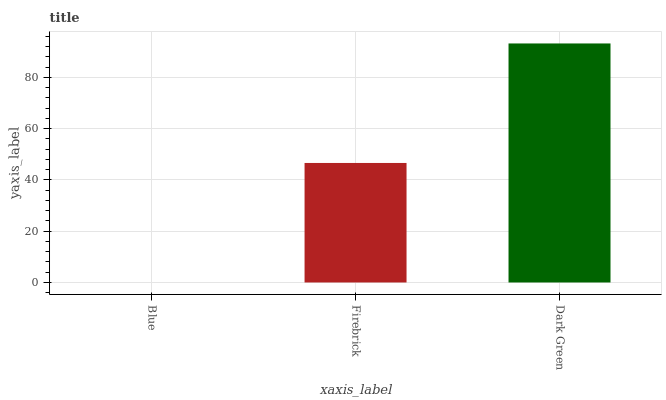Is Blue the minimum?
Answer yes or no. Yes. Is Dark Green the maximum?
Answer yes or no. Yes. Is Firebrick the minimum?
Answer yes or no. No. Is Firebrick the maximum?
Answer yes or no. No. Is Firebrick greater than Blue?
Answer yes or no. Yes. Is Blue less than Firebrick?
Answer yes or no. Yes. Is Blue greater than Firebrick?
Answer yes or no. No. Is Firebrick less than Blue?
Answer yes or no. No. Is Firebrick the high median?
Answer yes or no. Yes. Is Firebrick the low median?
Answer yes or no. Yes. Is Blue the high median?
Answer yes or no. No. Is Blue the low median?
Answer yes or no. No. 